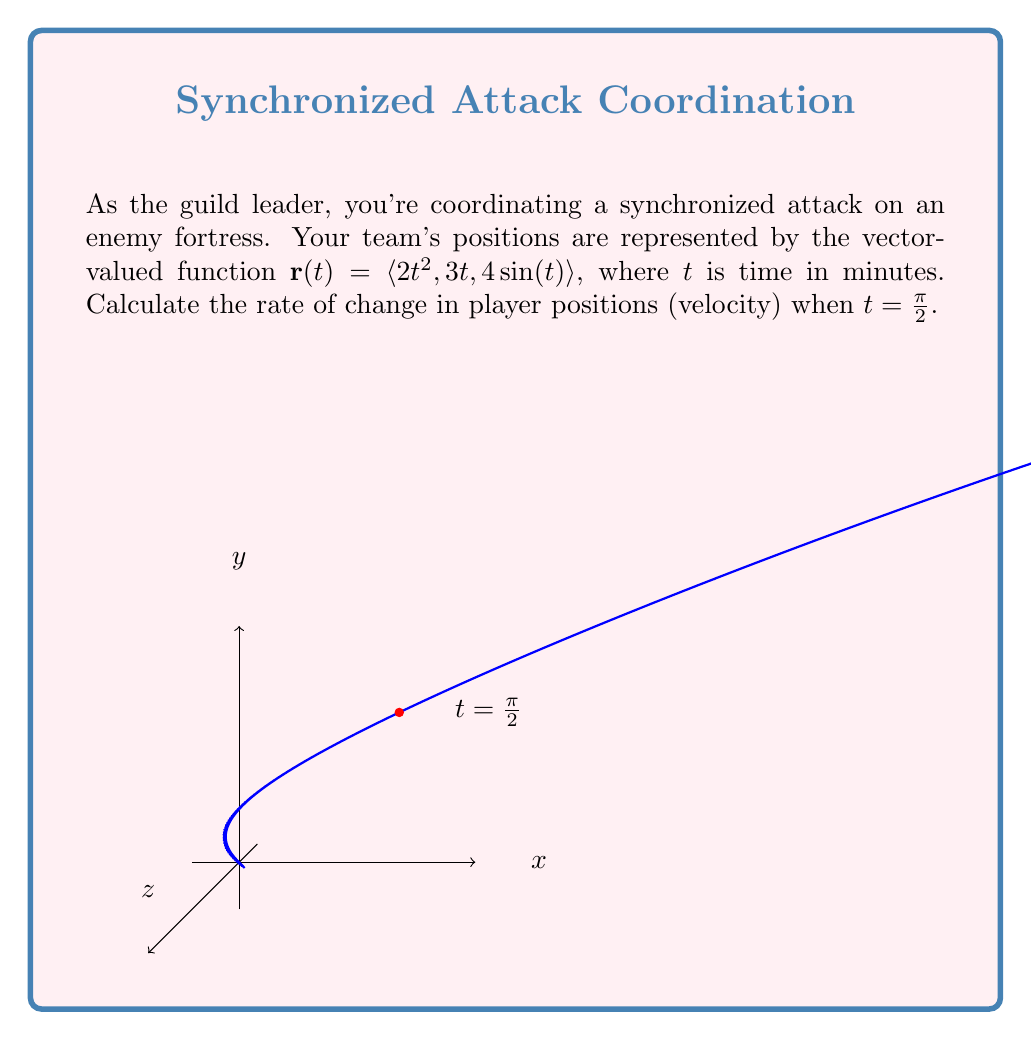Provide a solution to this math problem. To solve this problem, we need to follow these steps:

1) The velocity vector is the derivative of the position vector with respect to time. So, we need to calculate $\mathbf{r}'(t)$.

2) Let's differentiate each component of $\mathbf{r}(t)$:
   
   $\frac{d}{dt}(2t^2) = 4t$
   $\frac{d}{dt}(3t) = 3$
   $\frac{d}{dt}(4\sin(t)) = 4\cos(t)$

3) Therefore, the velocity vector is:
   
   $\mathbf{r}'(t) = \langle 4t, 3, 4\cos(t) \rangle$

4) Now, we need to evaluate this at $t = \frac{\pi}{2}$:
   
   $\mathbf{r}'(\frac{\pi}{2}) = \langle 4(\frac{\pi}{2}), 3, 4\cos(\frac{\pi}{2}) \rangle$

5) Simplify:
   - $4(\frac{\pi}{2}) = 2\pi$
   - $\cos(\frac{\pi}{2}) = 0$

6) Therefore, the final velocity vector is:

   $\mathbf{r}'(\frac{\pi}{2}) = \langle 2\pi, 3, 0 \rangle$

This vector represents the rate of change in player positions at $t = \frac{\pi}{2}$.
Answer: $\langle 2\pi, 3, 0 \rangle$ 